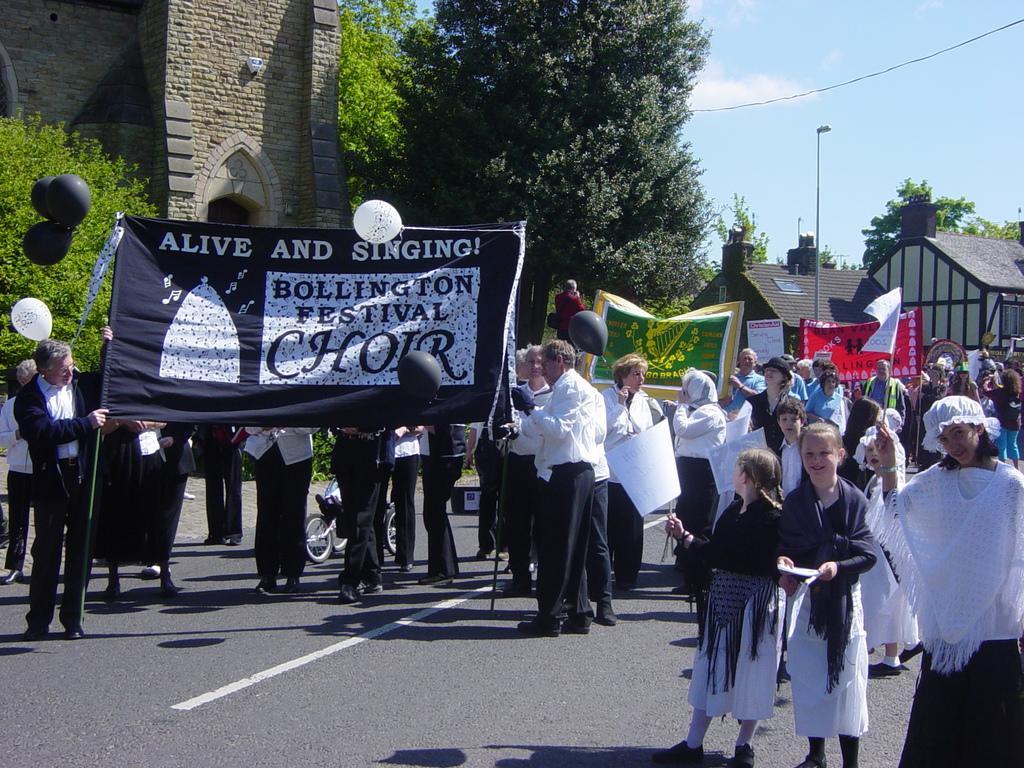In one or two sentences, can you explain what this image depicts? In this picture I can observe some people standing on the road. Some of them are holding black color poster in their hands. I can observe some text on this poster. There are men and women in this picture. In the background there are buildings, trees and a sky with some clouds. 